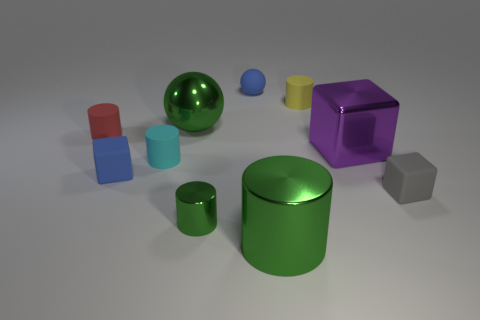Subtract all red cylinders. How many cylinders are left? 4 Subtract all tiny red matte cylinders. How many cylinders are left? 4 Subtract all gray cylinders. Subtract all green cubes. How many cylinders are left? 5 Subtract all spheres. How many objects are left? 8 Add 1 big purple blocks. How many big purple blocks exist? 2 Subtract 0 brown cylinders. How many objects are left? 10 Subtract all purple blocks. Subtract all yellow rubber objects. How many objects are left? 8 Add 8 purple metal objects. How many purple metal objects are left? 9 